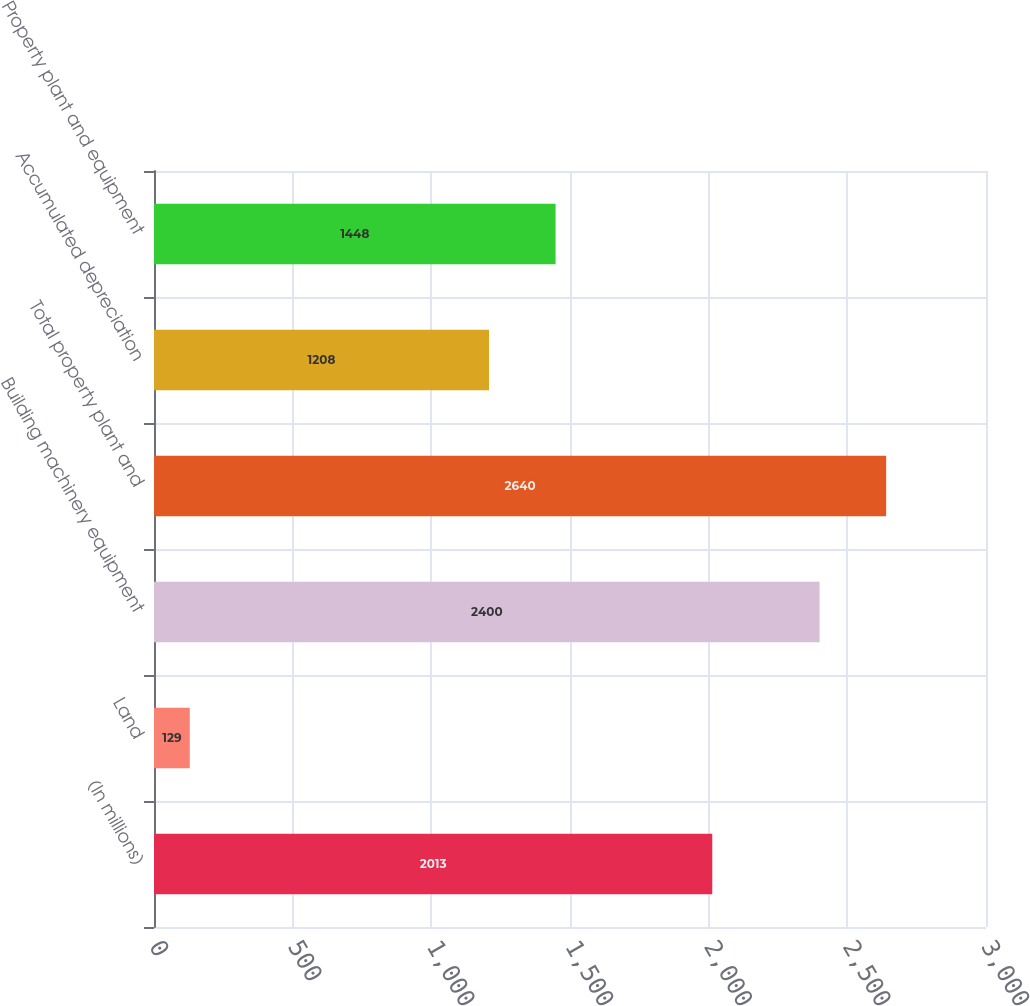Convert chart. <chart><loc_0><loc_0><loc_500><loc_500><bar_chart><fcel>(In millions)<fcel>Land<fcel>Building machinery equipment<fcel>Total property plant and<fcel>Accumulated depreciation<fcel>Property plant and equipment<nl><fcel>2013<fcel>129<fcel>2400<fcel>2640<fcel>1208<fcel>1448<nl></chart> 